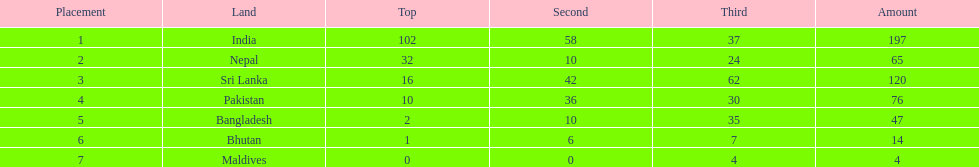Would you mind parsing the complete table? {'header': ['Placement', 'Land', 'Top', 'Second', 'Third', 'Amount'], 'rows': [['1', 'India', '102', '58', '37', '197'], ['2', 'Nepal', '32', '10', '24', '65'], ['3', 'Sri Lanka', '16', '42', '62', '120'], ['4', 'Pakistan', '10', '36', '30', '76'], ['5', 'Bangladesh', '2', '10', '35', '47'], ['6', 'Bhutan', '1', '6', '7', '14'], ['7', 'Maldives', '0', '0', '4', '4']]} Name a country listed in the table, other than india? Nepal. 